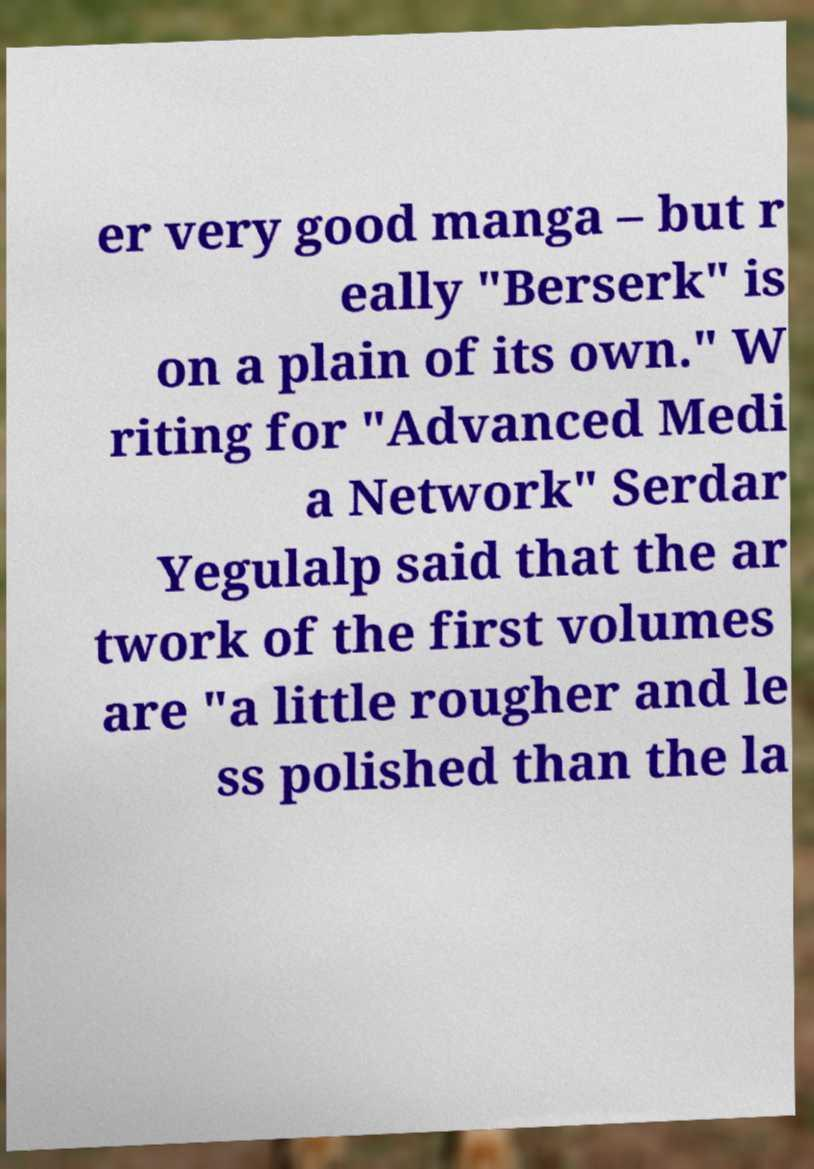Could you assist in decoding the text presented in this image and type it out clearly? er very good manga – but r eally "Berserk" is on a plain of its own." W riting for "Advanced Medi a Network" Serdar Yegulalp said that the ar twork of the first volumes are "a little rougher and le ss polished than the la 